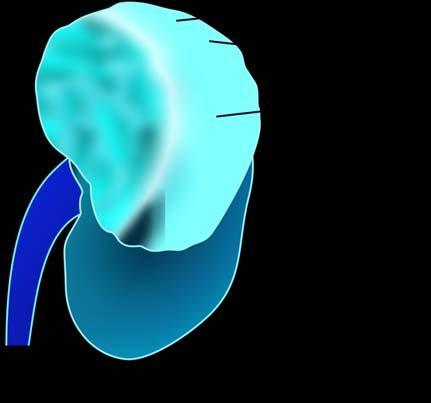how does sectioned surface show?
Answer the question using a single word or phrase. Irregular 